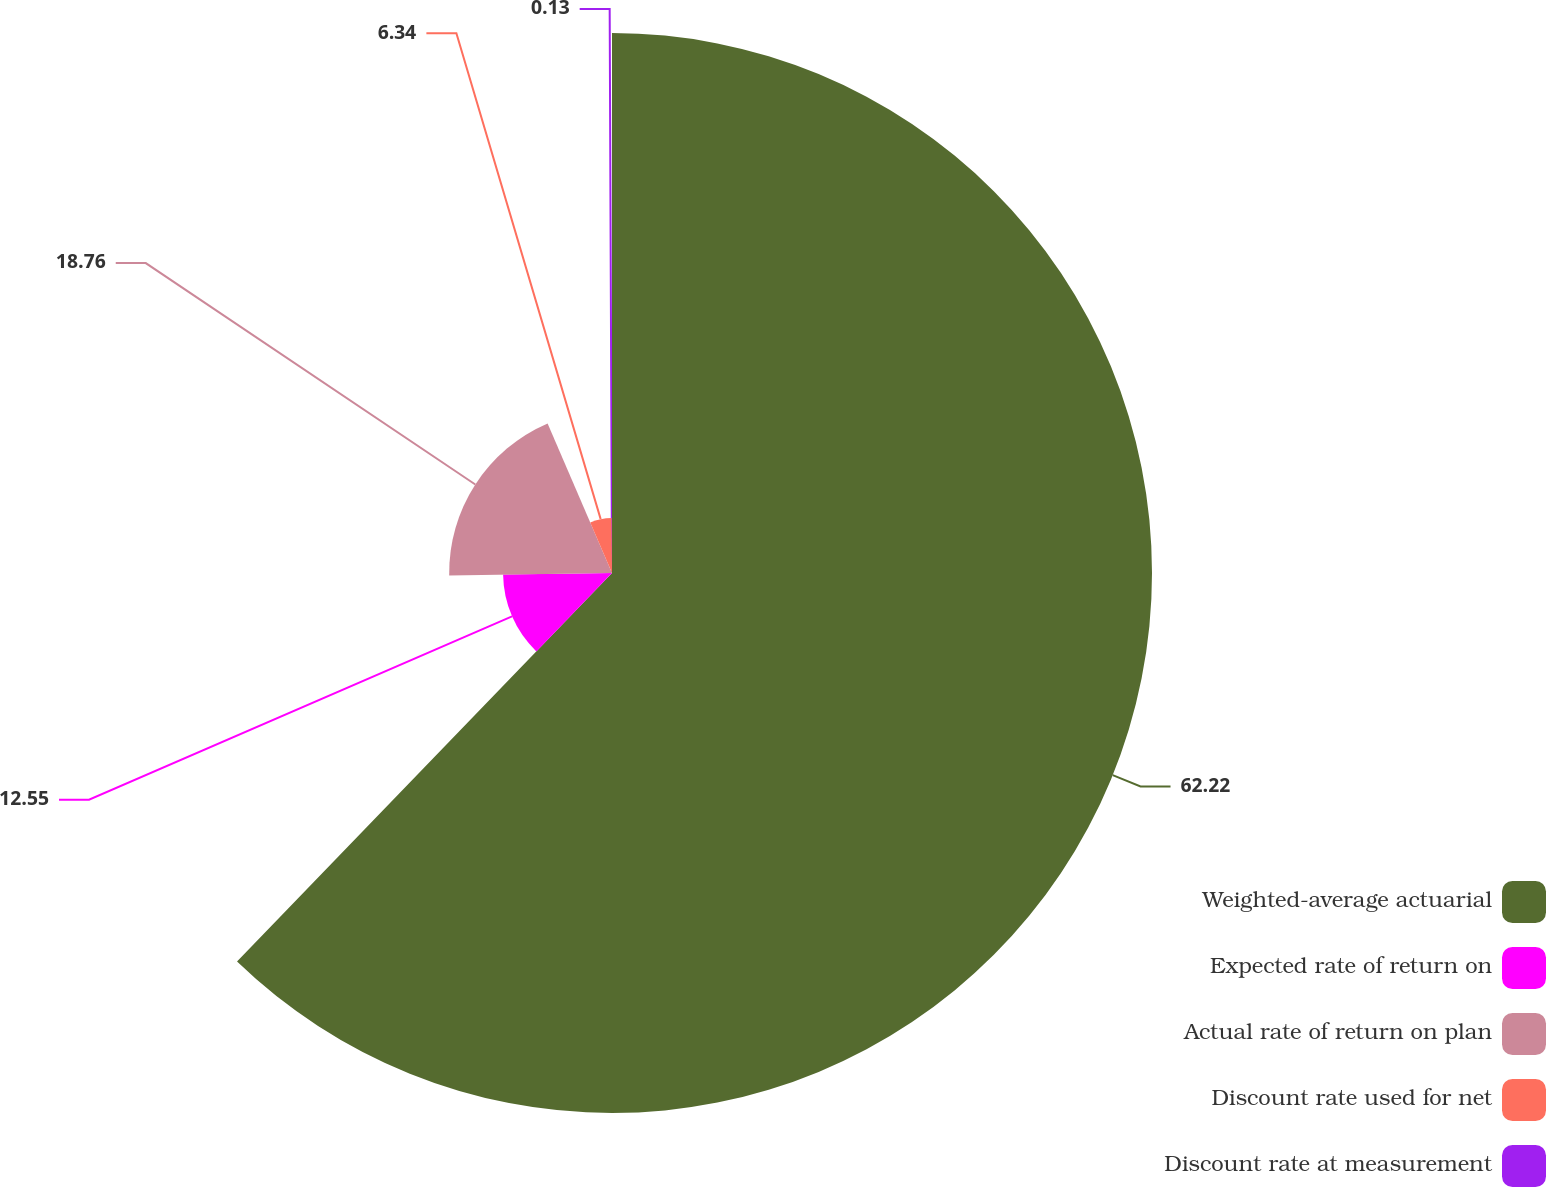Convert chart to OTSL. <chart><loc_0><loc_0><loc_500><loc_500><pie_chart><fcel>Weighted-average actuarial<fcel>Expected rate of return on<fcel>Actual rate of return on plan<fcel>Discount rate used for net<fcel>Discount rate at measurement<nl><fcel>62.21%<fcel>12.55%<fcel>18.76%<fcel>6.34%<fcel>0.13%<nl></chart> 